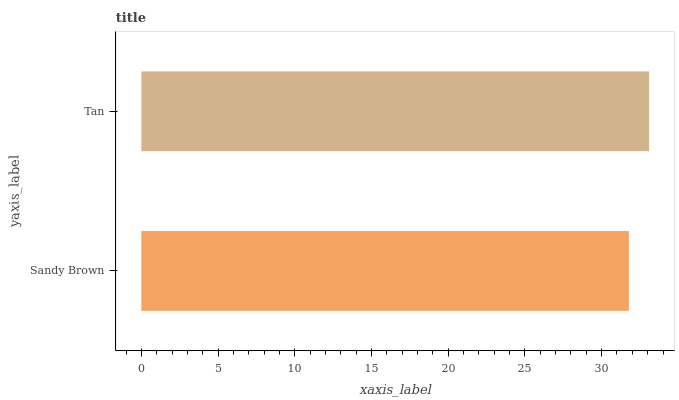Is Sandy Brown the minimum?
Answer yes or no. Yes. Is Tan the maximum?
Answer yes or no. Yes. Is Tan the minimum?
Answer yes or no. No. Is Tan greater than Sandy Brown?
Answer yes or no. Yes. Is Sandy Brown less than Tan?
Answer yes or no. Yes. Is Sandy Brown greater than Tan?
Answer yes or no. No. Is Tan less than Sandy Brown?
Answer yes or no. No. Is Tan the high median?
Answer yes or no. Yes. Is Sandy Brown the low median?
Answer yes or no. Yes. Is Sandy Brown the high median?
Answer yes or no. No. Is Tan the low median?
Answer yes or no. No. 